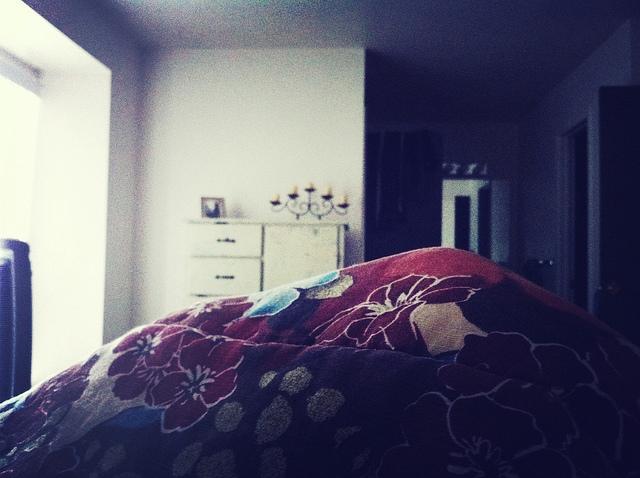Is someone sleeping under the blanket?
Give a very brief answer. Yes. How many candles in the background?
Quick response, please. 5. What design is on the blanket?
Concise answer only. Flowers. 